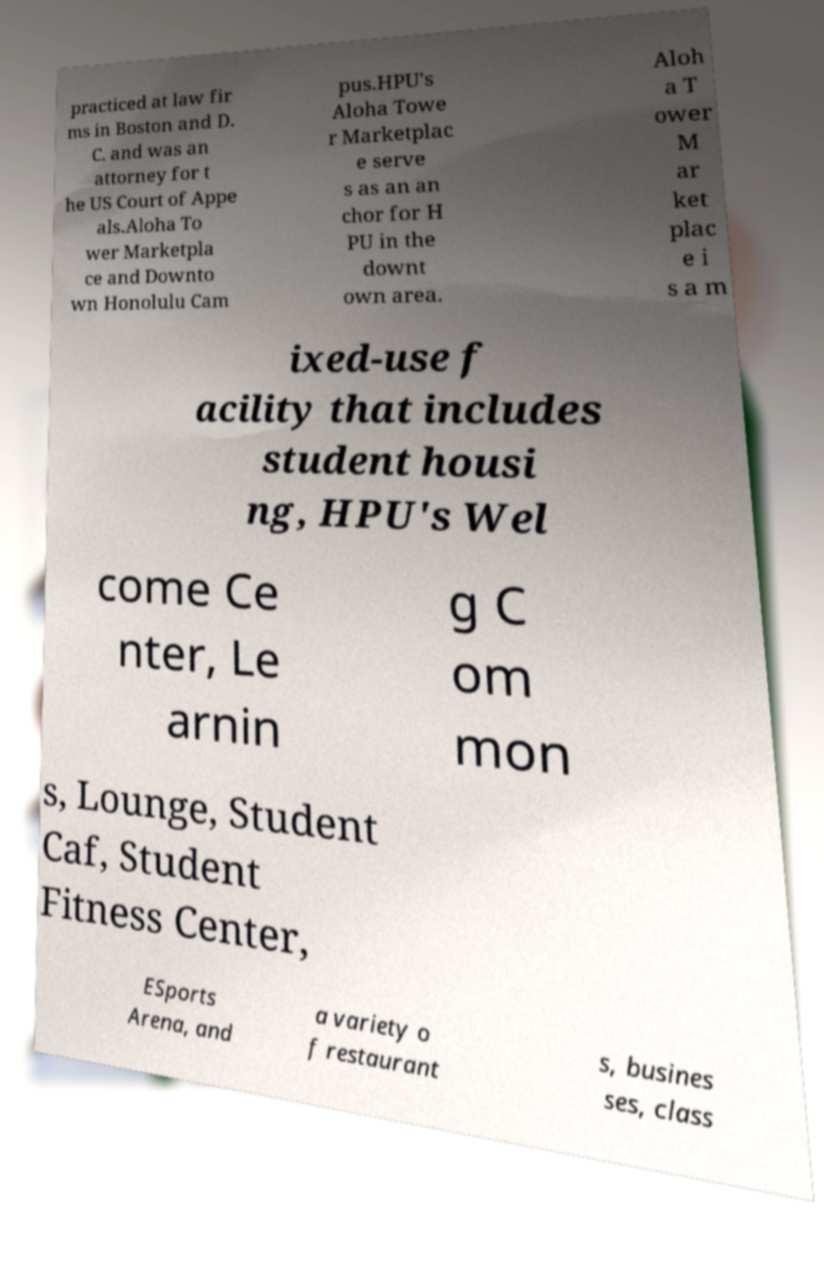What messages or text are displayed in this image? I need them in a readable, typed format. practiced at law fir ms in Boston and D. C. and was an attorney for t he US Court of Appe als.Aloha To wer Marketpla ce and Downto wn Honolulu Cam pus.HPU's Aloha Towe r Marketplac e serve s as an an chor for H PU in the downt own area. Aloh a T ower M ar ket plac e i s a m ixed-use f acility that includes student housi ng, HPU's Wel come Ce nter, Le arnin g C om mon s, Lounge, Student Caf, Student Fitness Center, ESports Arena, and a variety o f restaurant s, busines ses, class 